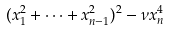Convert formula to latex. <formula><loc_0><loc_0><loc_500><loc_500>( x _ { 1 } ^ { 2 } + \dots + x _ { n - 1 } ^ { 2 } ) ^ { 2 } - \nu x _ { n } ^ { 4 }</formula> 